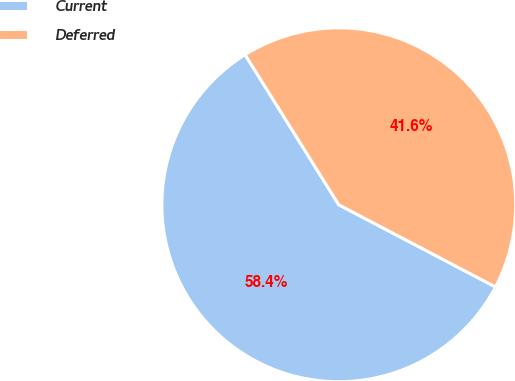<chart> <loc_0><loc_0><loc_500><loc_500><pie_chart><fcel>Current<fcel>Deferred<nl><fcel>58.43%<fcel>41.57%<nl></chart> 